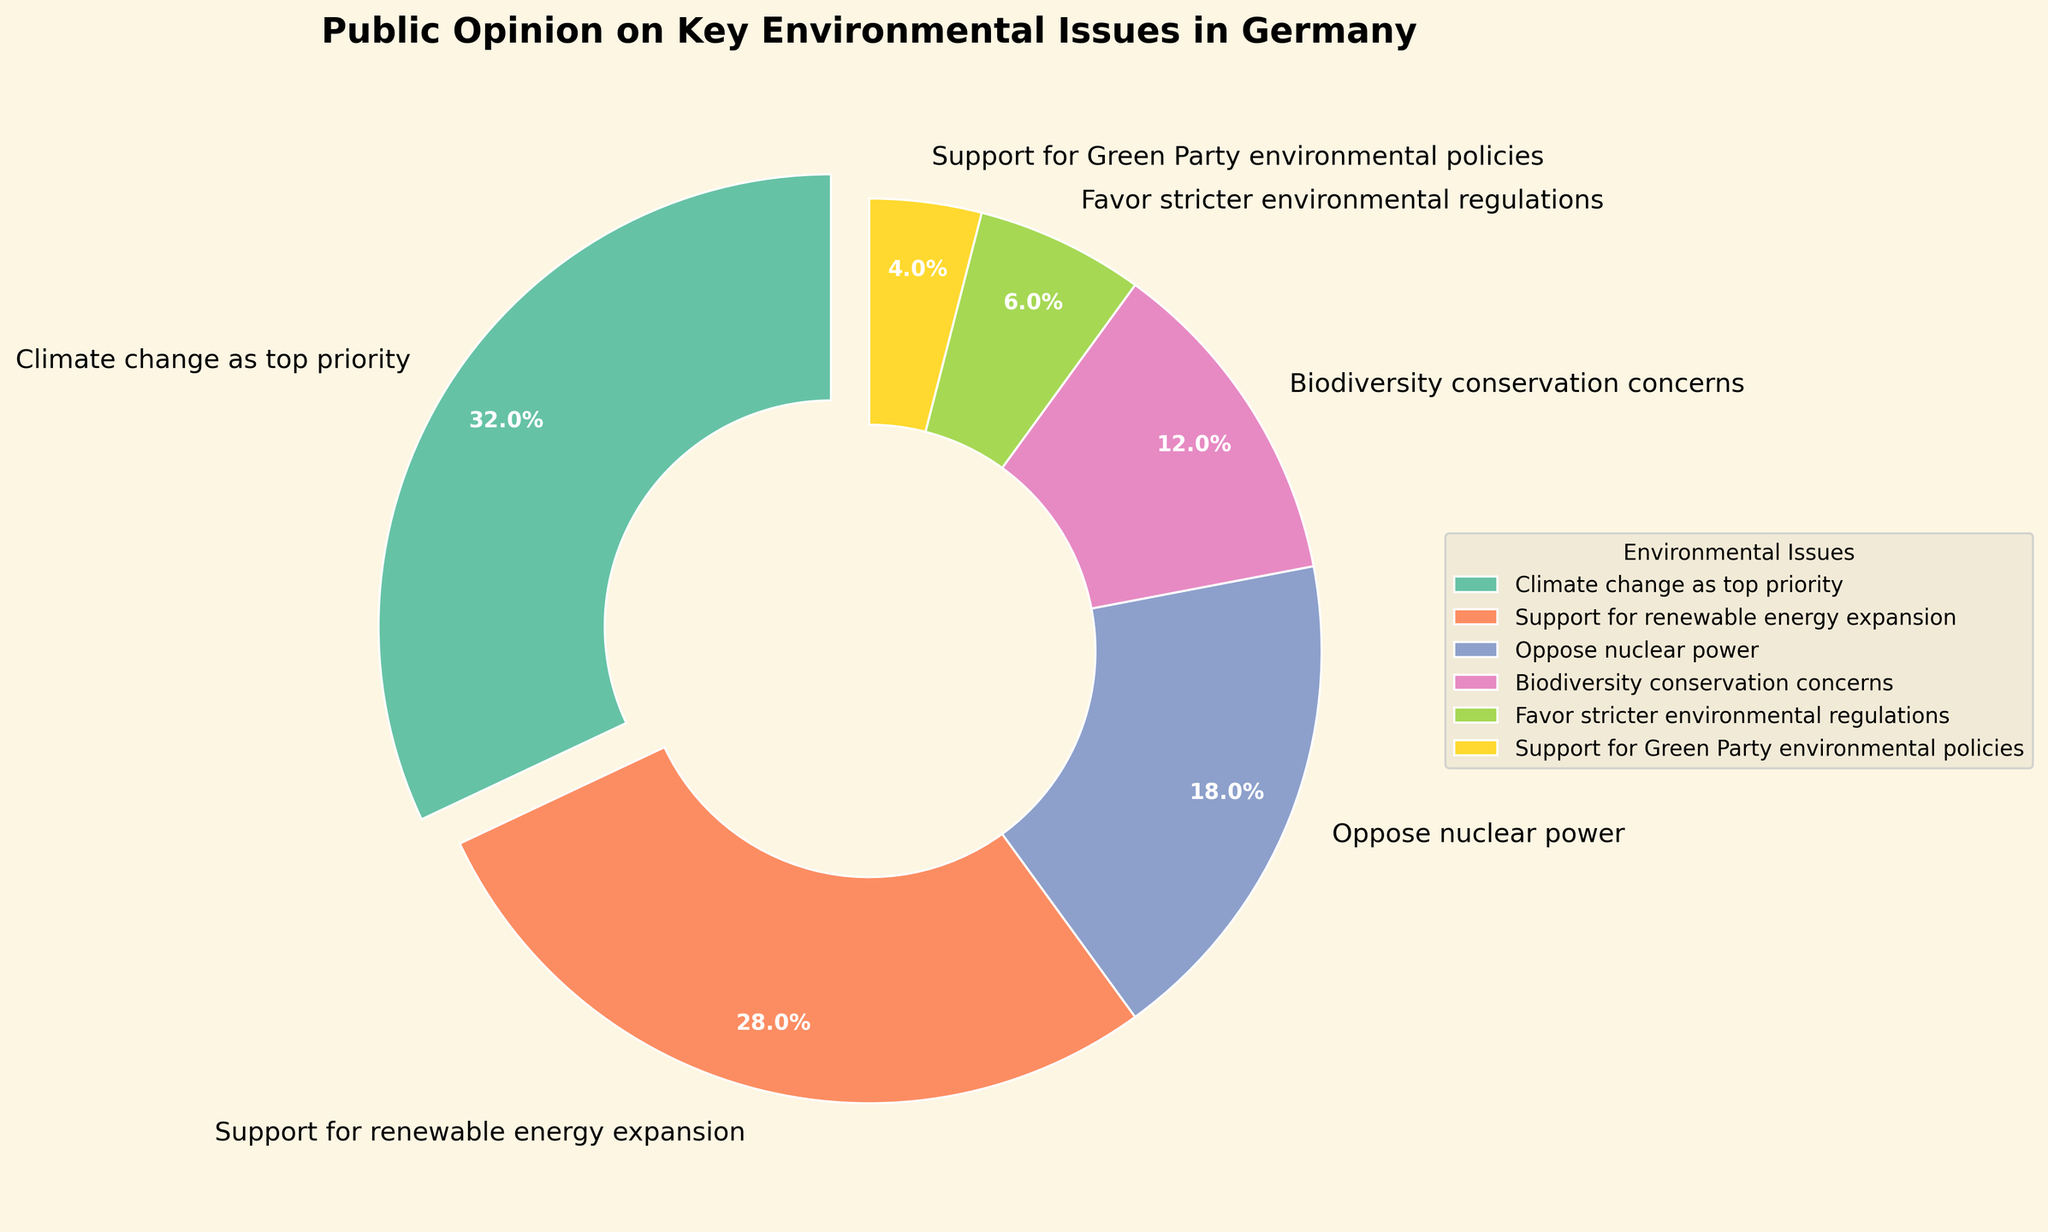Which issue has the highest percentage of public opinion? By looking at the pie chart, find the segment with the largest percentage value.
Answer: Climate change as top priority Which issue is represented by the smallest segment in the pie chart? Identify the segment with the smallest percentage value in the pie chart.
Answer: Support for Green Party environmental policies What is the total percentage of public opinion that is either concerned with biodiversity conservation or favors stricter environmental regulations? Sum the percentages of the segments labeled "Biodiversity conservation concerns" and "Favor stricter environmental regulations." 12 + 6 = 18
Answer: 18 Are there more people who support renewable energy expansion or those who oppose nuclear power? Compare the percentage of the segment labeled "Support for renewable energy expansion" with the one labeled "Oppose nuclear power." 28 > 18
Answer: Renewable energy expansion What percentage of the public does not list climate change as the top priority? Subtract the percentage of the segment labeled "Climate change as top priority" from 100. 100 - 32 = 68
Answer: 68 If the combined percentage of supporting the Green Party environmental policies and favoring stricter environmental regulations were to increase by 10%, what would their new total percentage be? First, sum their current percentages: 4 + 6 = 10. Then, add 10 to that sum. 10 + 10 = 20
Answer: 20 What is the difference in percentage between those who support renewable energy expansion and those concerned with biodiversity conservation? Subtract the percentage of "Biodiversity conservation concerns" from "Support for renewable energy expansion." 28 - 12 = 16
Answer: 16 Does the percentage of people opposing nuclear power exceed the percentage of those favoring stricter environmental regulations by more than 10 percentage points? Subtract the percentage of "Favor stricter environmental regulations" from "Oppose nuclear power" and check if the result is greater than 10. 18 - 6 = 12, which is greater than 10
Answer: Yes Which environmental issue has a percentage closest to the average percentage of all issues represented? Calculate the average percentage and find the segment closest to this value. The total percentage is 100, divided by 6 issues: 100/6 ≈ 16.7. "Oppose nuclear power" at 18 is closest to 16.7.
Answer: Oppose nuclear power 